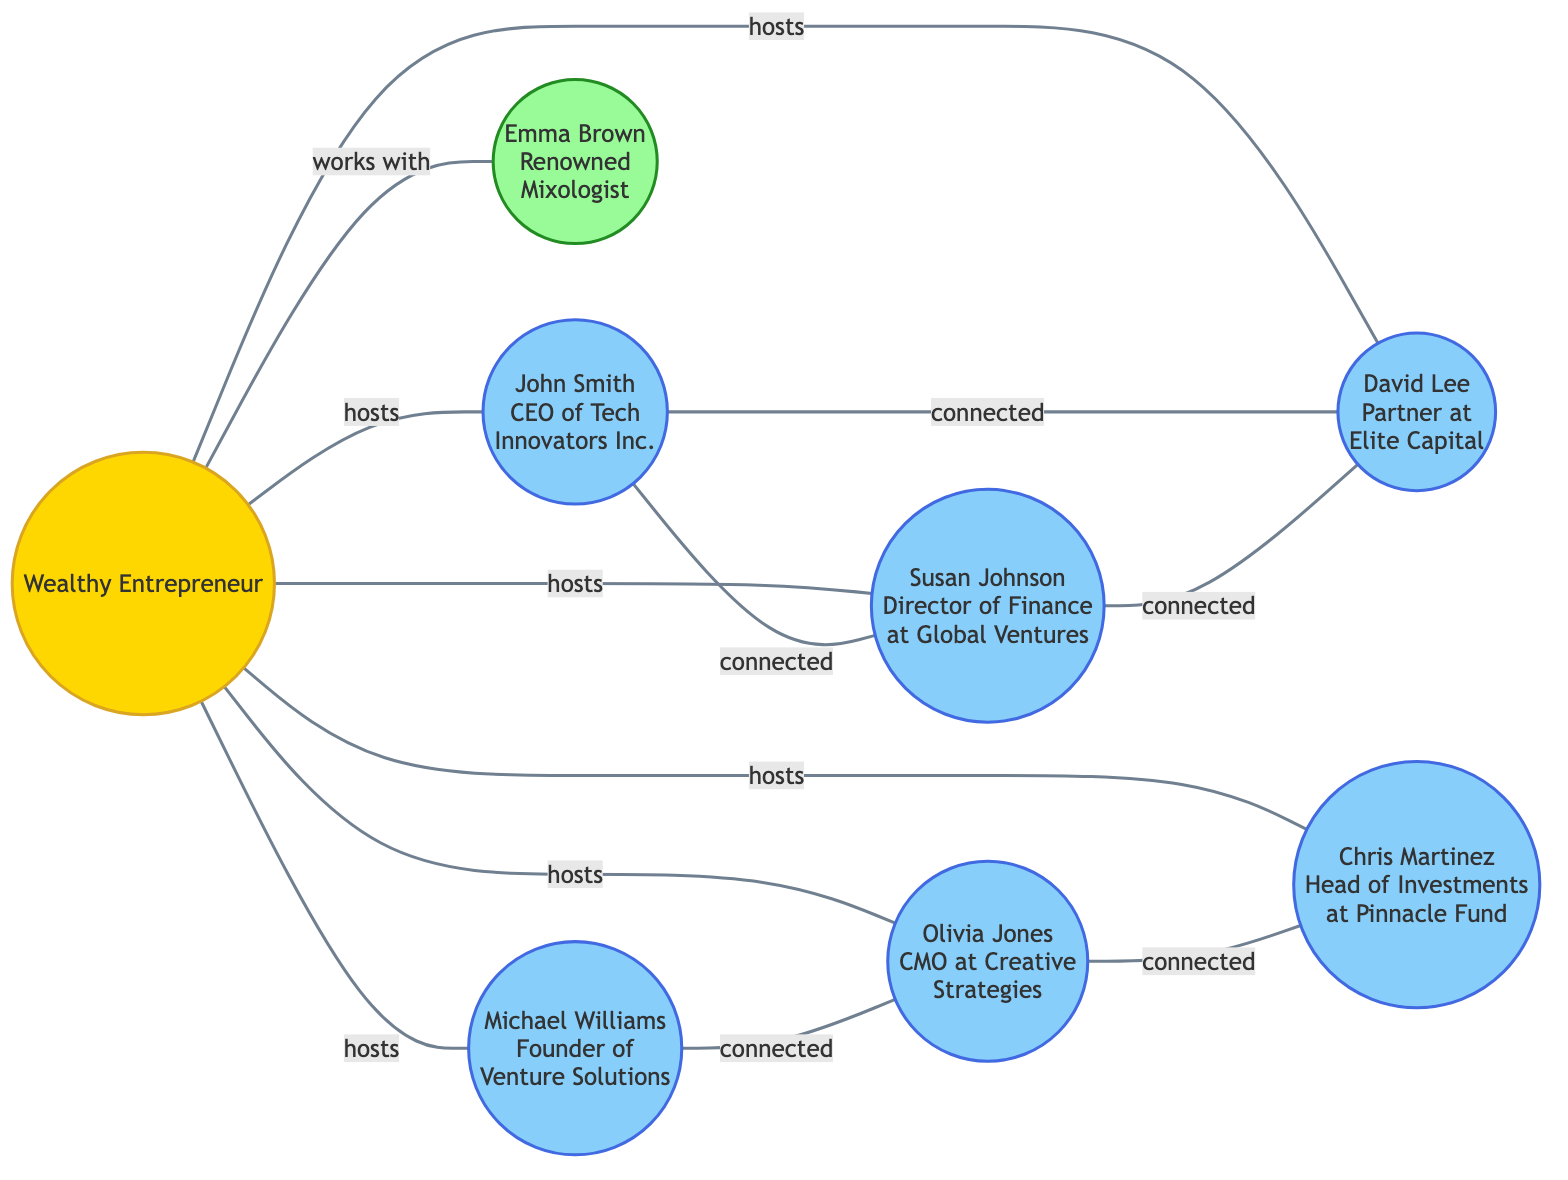What is the total number of nodes in the diagram? To find the total number of nodes, we can count each unique entity represented in the diagram. The nodes are the wealthy entrepreneur, business contacts, and the mixologist. In total, there are 8 distinct entities.
Answer: 8 Which business contact is directly connected to both John Smith and David Lee? By looking at the edges connected to John Smith and David Lee, we see that Susan Johnson is directly connected to John Smith, and she is also connected to David Lee, forming a bridge between them.
Answer: Susan Johnson How many connections are established by the entrepreneur? The entrepreneur has 7 direct connections established through hosting events, which includes connections to John Smith, Susan Johnson, David Lee, Michael Williams, Olivia Jones, and Chris Martinez, as well as working with Emma Brown.
Answer: 7 Which business contact works with the entrepreneur? The entrepreneur has a direct connection labeled "works with" to Emma Brown, indicating that she collaborates with him, unlike the other connections that are hosting relationships.
Answer: Emma Brown How many edges connect the business contacts among themselves? In total, there are 4 edges representing connections among the business contacts: John Smith is connected to both Susan Johnson and David Lee; Michael Williams is connected to Olivia Jones; and Olivia Jones is connected to Chris Martinez. Counting these pairs gives us a total of 4 edges.
Answer: 4 What is the relationship between Olivia Jones and Chris Martinez? The relationship between Olivia Jones and Chris Martinez is indicated as "connected" in the diagram, establishing a direct business link between them.
Answer: connected Which node represents the renowned mixologist? The only node that specifically identifies a mixologist with the title of renowned is labeled Emma Brown in the current network diagram.
Answer: Emma Brown Identify the highest number of connections held by a single business contact. By reviewing the connections, we see that both John Smith and David Lee each have 2 connections to other business contacts, making them the most interconnected among the business contacts.
Answer: 2 